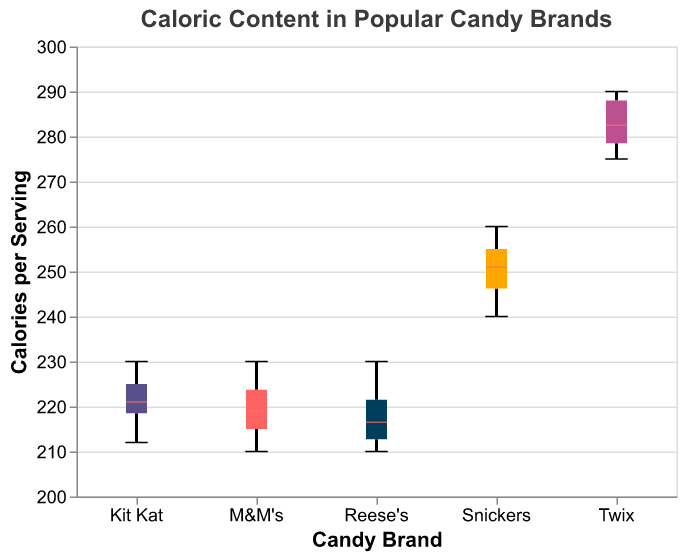What is the median caloric content of Snickers? The median is represented by a distinct notch or line in the middle of the box plot for Snickers.
Answer: 252 Which candy brand has the lowest caloric content in its lower whisker range? The lower whisker of the box plot that extends to the lowest value represents the minimum caloric content. Reese's has the lowest caloric content, at 210.
Answer: Reese's What is the interquartile range (IQR) of the caloric content for M&M's? The IQR is the range between the upper quartile (75th percentile) and the lower quartile (25th percentile). For M&M's, these values can be found at the edges of the box in the box plot. Calculate (225 - 215) to get the IQR.
Answer: 10 Which brand has the highest median caloric content? Compare the median lines (notches) for each brand. Twix has the highest median caloric content, represented by its median being higher than those of the other brands.
Answer: Twix Does Kit Kat's caloric content vary more or less than Reese's? By comparing the lengths of the boxes from the lower quartile to the upper quartile for each brand, we see that Kit Kat's box is slightly larger, indicating more variability in caloric content.
Answer: More What is the difference between the maximum and minimum caloric content for Twix? Examine the top and bottom whiskers of the Twix box plot, the maximum is 290 and the minimum is 275. Calculate the difference (290 - 275).
Answer: 15 How does the median caloric content of M&M's compare to that of Reese's? Compare the median (notch) lines for both M&M's and Reese's. M&M's median is roughly 220, and Reese's is slightly less, but also around 220.
Answer: Similar Which brand has the widest range of caloric content? Look at the length of the whiskers plus the boxes for each brand. Twix has the widest range of caloric content.
Answer: Twix Does Snickers have any outliers? Outliers are shown as individual dots outside the whiskers. Snickers does not have any such dots, indicating no outliers.
Answer: No What is the median value of Reese's and Kit Kat combined? Note the median values for Reese's and Kit Kat. Reese's median is around 215, and Kit Kat's is around 222. Average these values ((215 + 222) / 2).
Answer: 218.5 